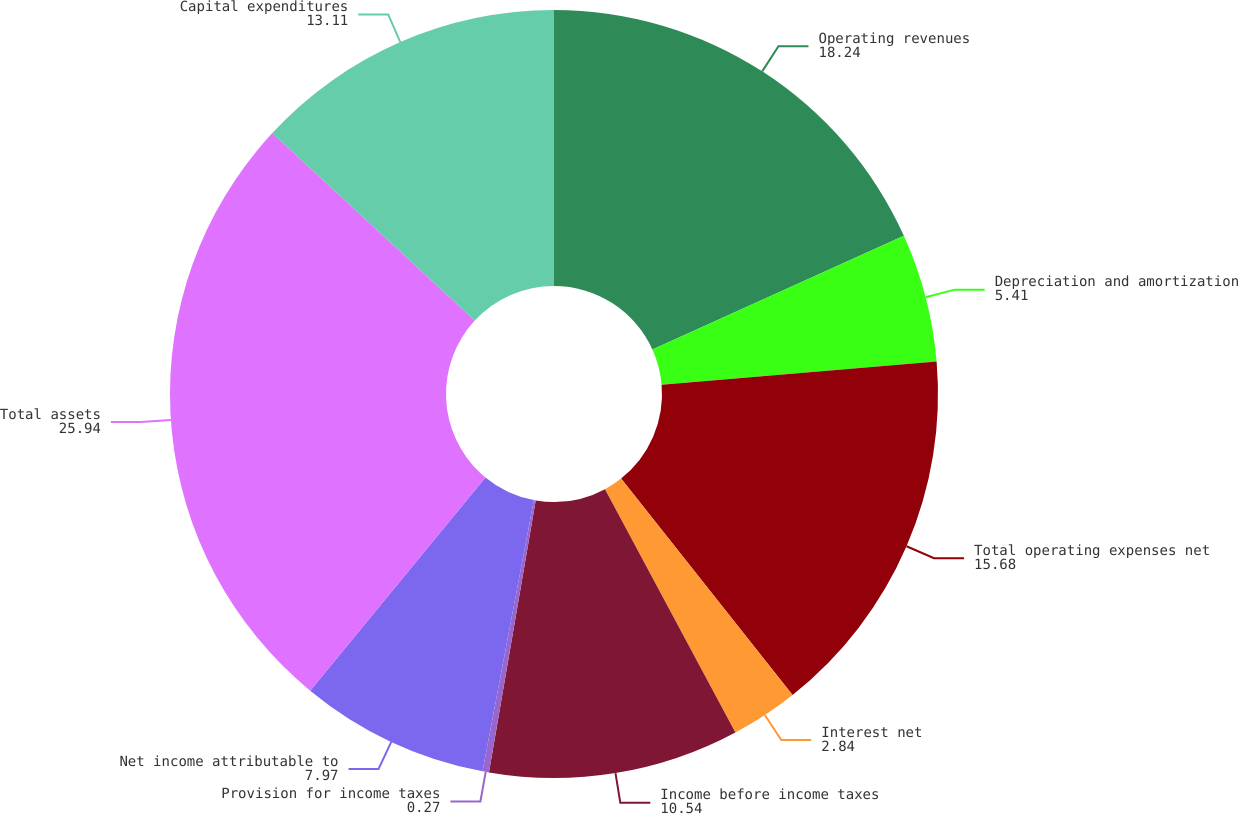Convert chart to OTSL. <chart><loc_0><loc_0><loc_500><loc_500><pie_chart><fcel>Operating revenues<fcel>Depreciation and amortization<fcel>Total operating expenses net<fcel>Interest net<fcel>Income before income taxes<fcel>Provision for income taxes<fcel>Net income attributable to<fcel>Total assets<fcel>Capital expenditures<nl><fcel>18.24%<fcel>5.41%<fcel>15.68%<fcel>2.84%<fcel>10.54%<fcel>0.27%<fcel>7.97%<fcel>25.94%<fcel>13.11%<nl></chart> 